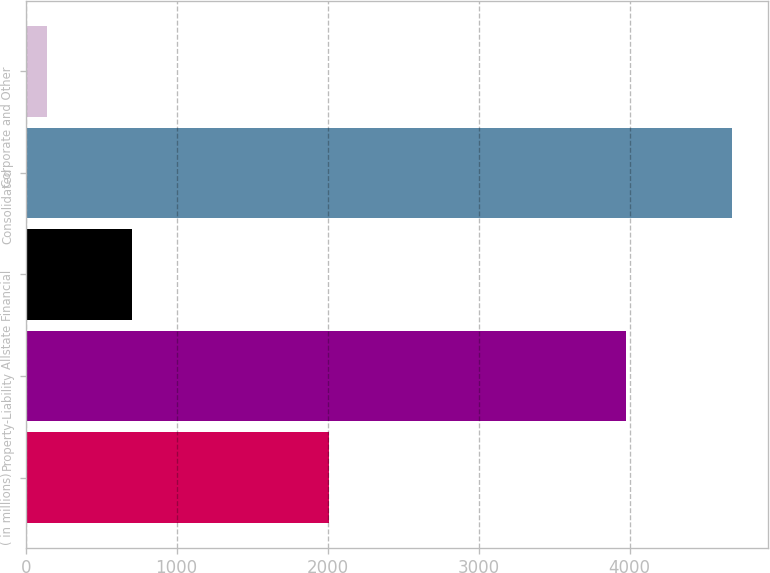Convert chart. <chart><loc_0><loc_0><loc_500><loc_500><bar_chart><fcel>( in millions)<fcel>Property-Liability<fcel>Allstate Financial<fcel>Consolidated<fcel>Corporate and Other<nl><fcel>2008<fcel>3975<fcel>704<fcel>4679<fcel>144<nl></chart> 